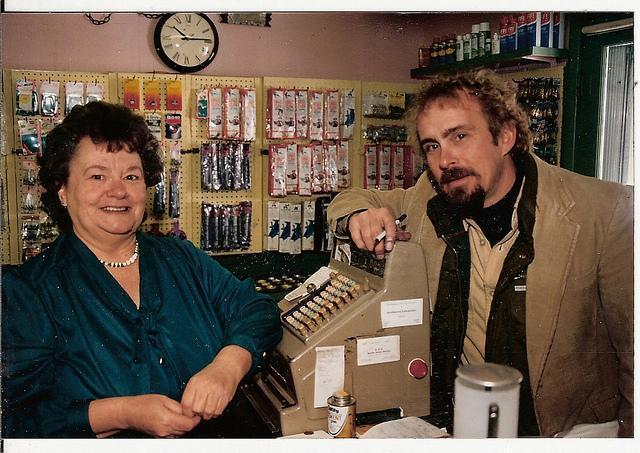How many clocks are in the photo?
Give a very brief answer. 1. How many people are there?
Give a very brief answer. 2. How many benches are on the left of the room?
Give a very brief answer. 0. 